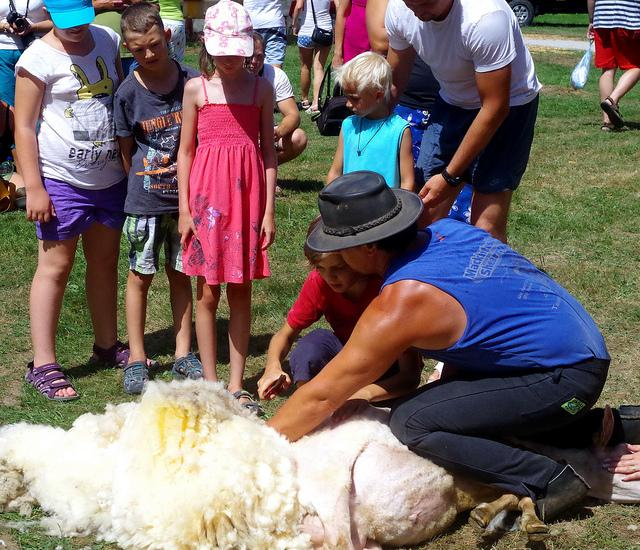Why is the animal on the ground? Please explain your reasoning. shearing. The sheep is laying on the ground because it is being sheared for its wool. 